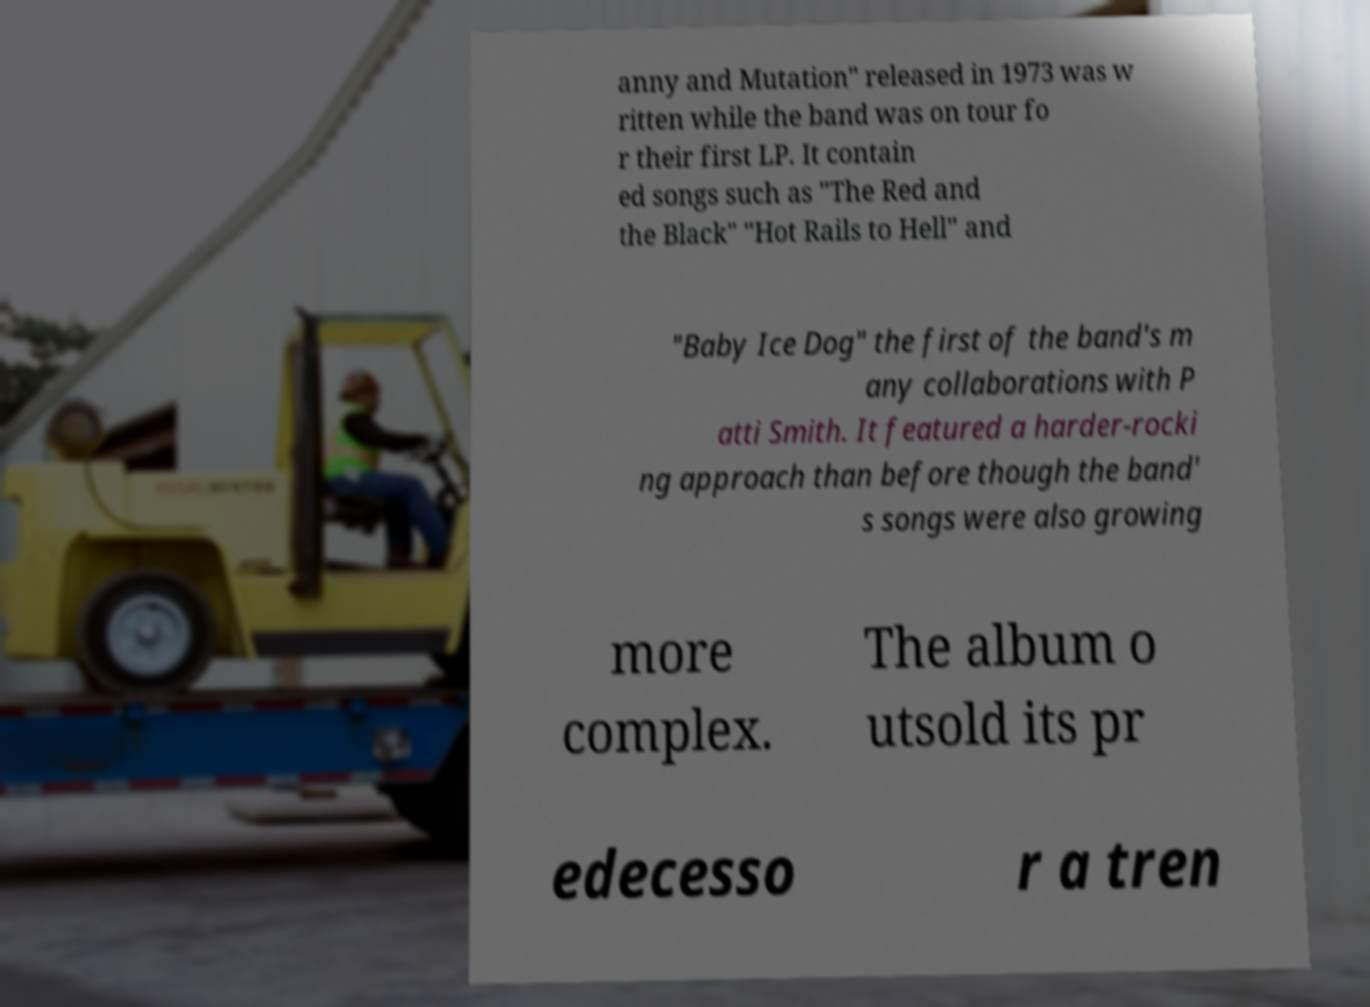Can you read and provide the text displayed in the image?This photo seems to have some interesting text. Can you extract and type it out for me? anny and Mutation" released in 1973 was w ritten while the band was on tour fo r their first LP. It contain ed songs such as "The Red and the Black" "Hot Rails to Hell" and "Baby Ice Dog" the first of the band's m any collaborations with P atti Smith. It featured a harder-rocki ng approach than before though the band' s songs were also growing more complex. The album o utsold its pr edecesso r a tren 